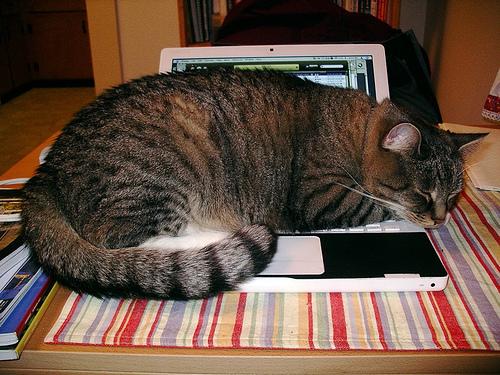What is the animal doing?
Short answer required. Sleeping. Is this in a home?
Quick response, please. Yes. What is the animal lying on?
Quick response, please. Laptop. How many cats?
Give a very brief answer. 1. 